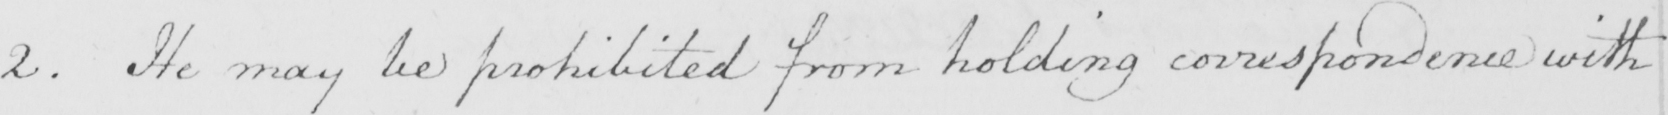Transcribe the text shown in this historical manuscript line. 2 . He may be prohibited from holding correspondence with 